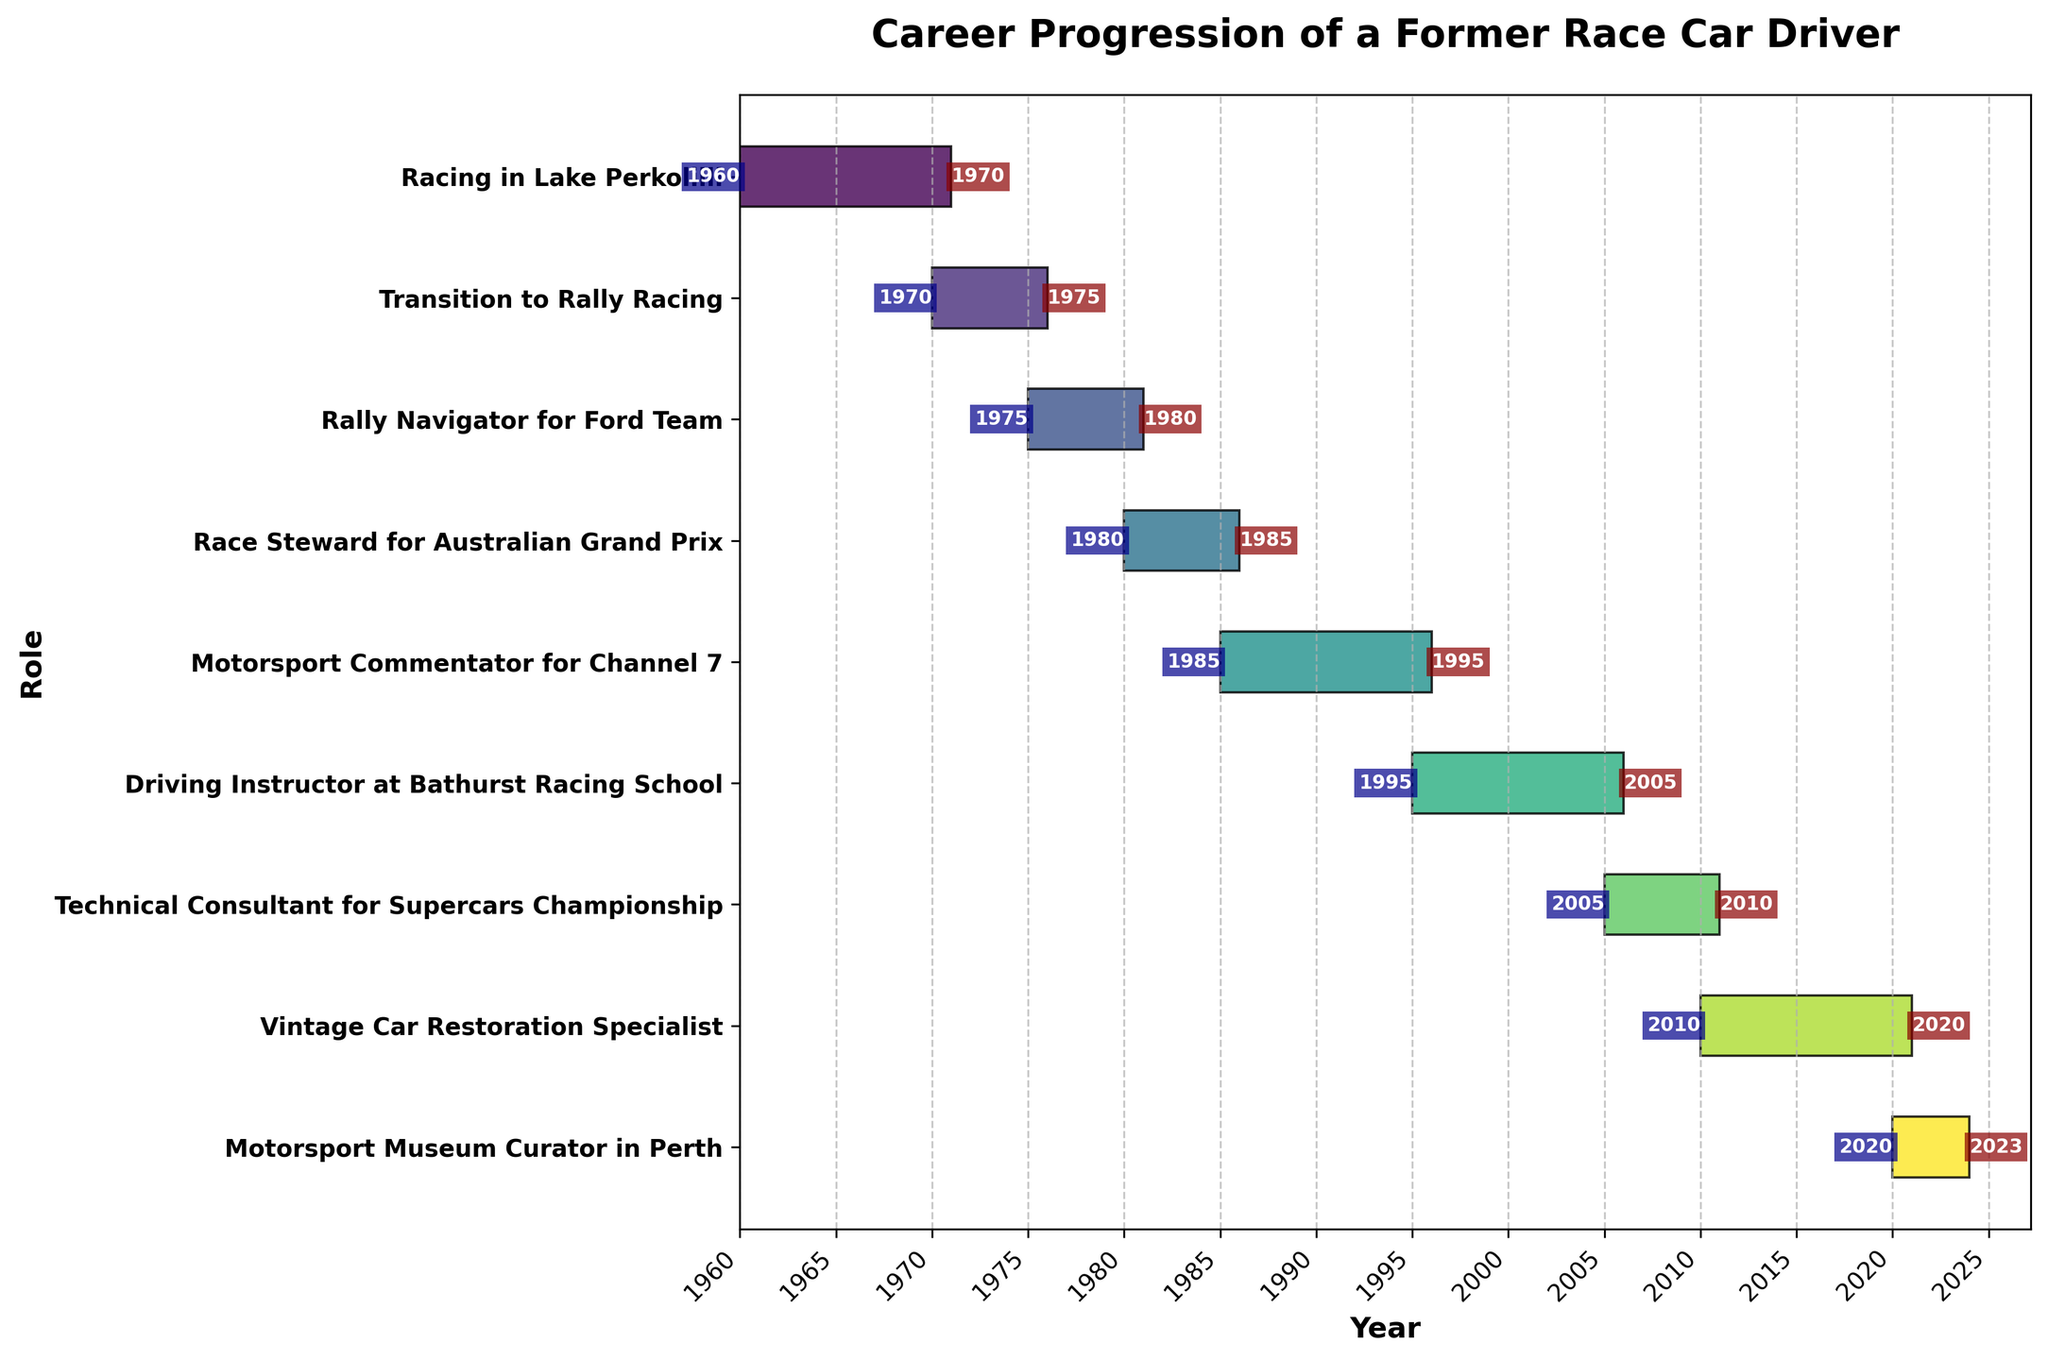What is the title of the Gantt chart? The title is typically located at the top of the Gantt chart, providing a summary of the chart's contents. Here, "Career Progression of a Former Race Car Driver" is written as the title, summarizing the career transitions shown in the chart.
Answer: Career Progression of a Former Race Car Driver Which role did the driver transition to after racing in Lake Perkolilli? To determine this, find the end year of "Racing in Lake Perkolilli" (1970) and look at the role that starts in that year. The next task is "Transition to Rally Racing" starting in 1970.
Answer: Transition to Rally Racing For how many years did the driver work as a Rally Navigator for the Ford Team? Check the start and end years for "Rally Navigator for Ford Team," which are 1975 and 1980, respectively. Subtract 1975 from 1980 to get the duration.
Answer: 5 years Which role did the driver have the longest tenure? By comparing the lengths of the bars representing each task, you see that "Vintage Car Restoration Specialist" (2010-2020) spans the longest duration, which is 10 years.
Answer: Vintage Car Restoration Specialist Which roles did the driver have during the 1980s? Examine the chart to locate the tasks overlapping with years in the 1980s. These roles include "Race Steward for Australian Grand Prix" (1980-1985) and "Motorsport Commentator for Channel 7" (1985-1995).
Answer: Race Steward for Australian Grand Prix, Motorsport Commentator for Channel 7 Does any role in the chart overlap with both the 1970s and 1980s? Inspect roles spanning the years and check if a single role covers both decades. "Rally Navigator for Ford Team" spans from 1975 to 1980, which covers both decades.
Answer: Yes, Rally Navigator for Ford Team What roles did the driver hold for exactly 5 years? Identify tasks that start and end with exactly 5-year differences: "Transition to Rally Racing" (1970-1975), "Rally Navigator for Ford Team" (1975-1980), and "Race Steward for Australian Grand Prix" (1980-1985).
Answer: Transition to Rally Racing, Rally Navigator for Ford Team, Race Steward for Australian Grand Prix How many roles did the driver transition through before becoming a Motorsport Commentator for Channel 7? Count the number of roles from the start until the "Motorsport Commentator for Channel 7." Those roles include: "Racing in Lake Perkolilli," "Transition to Rally Racing," "Rally Navigator for Ford Team," and "Race Steward for Australian Grand Prix."
Answer: 4 roles Which roles occupied the last decade of the driver's career? Review the roles spanning from 2010 to 2020 and beyond. These include "Vintage Car Restoration Specialist" (2010-2020) and "Motorsport Museum Curator in Perth" (2020-2023).
Answer: Vintage Car Restoration Specialist, Motorsport Museum Curator in Perth 